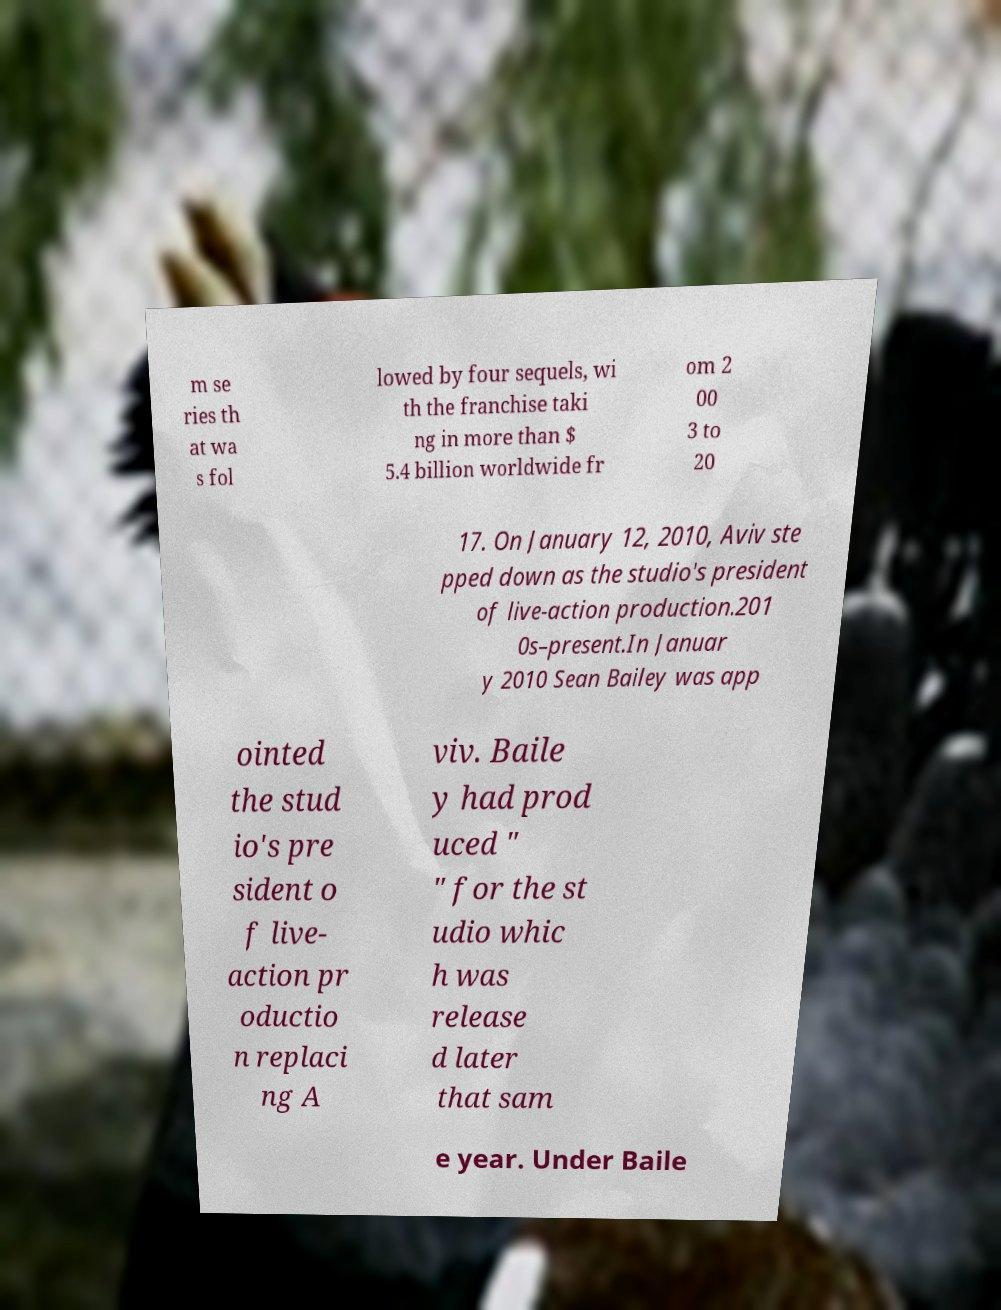What messages or text are displayed in this image? I need them in a readable, typed format. m se ries th at wa s fol lowed by four sequels, wi th the franchise taki ng in more than $ 5.4 billion worldwide fr om 2 00 3 to 20 17. On January 12, 2010, Aviv ste pped down as the studio's president of live-action production.201 0s–present.In Januar y 2010 Sean Bailey was app ointed the stud io's pre sident o f live- action pr oductio n replaci ng A viv. Baile y had prod uced " " for the st udio whic h was release d later that sam e year. Under Baile 